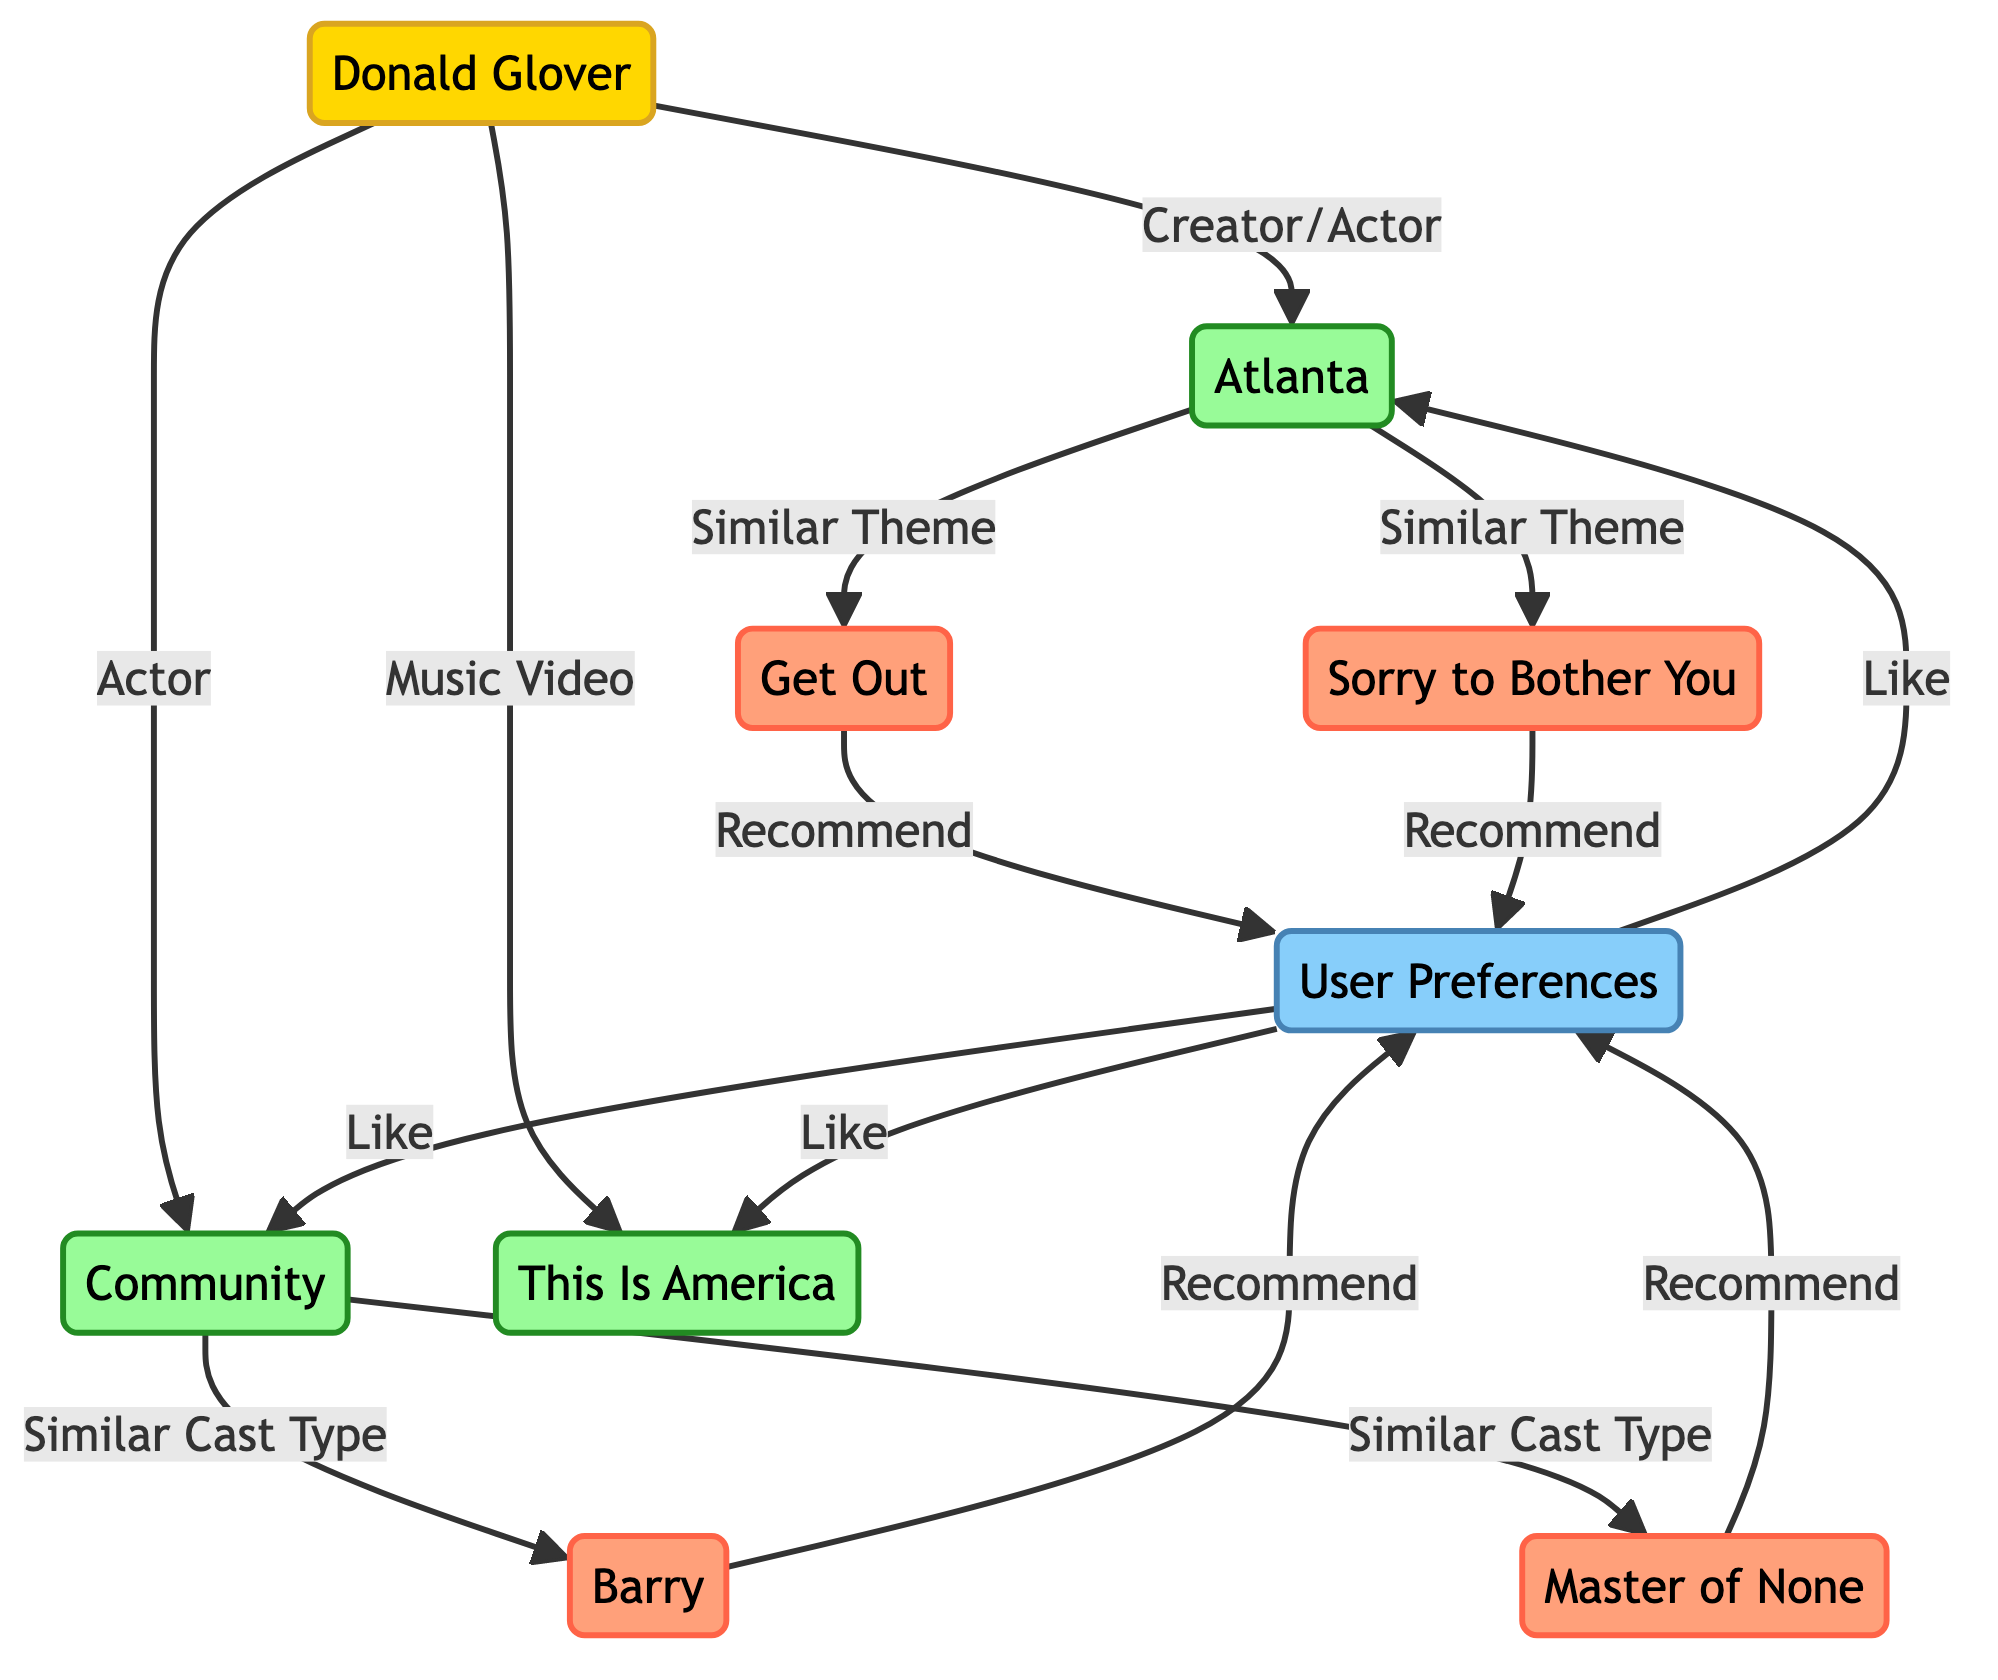What are the user preferences linked to in the diagram? The user preferences are linked to Atlanta, Community, and This Is America, as indicated by the arrows. Each shows the user's liking.
Answer: Atlanta, Community, This Is America How many movies are recommended in the diagram? There are two movies recommended (Get Out and Sorry to Bother You) based on their connections from Atlanta, which is liked by the user.
Answer: 2 Who is the central figure represented in the diagram? The central figure is Donald Glover. He is shown as a key node with connections to content and user preferences.
Answer: Donald Glover What type of relationship exists between Atlanta and Get Out? The relationship is a "Similar Theme," indicated by the labeling on the connecting edge from Atlanta to Get Out.
Answer: Similar Theme Which shows are related to Community in the diagram? The shows related to Community are Barry and Master of None, as indicated by the connections showing "Similar Cast Type."
Answer: Barry, Master of None What type of content is linked to "This Is America"? This Is America has a direct connection labeled as "Music Video" from Donald Glover, indicating its type of content.
Answer: Music Video How many content nodes are present in the diagram? Counting Atlanta, Community, This Is America, Get Out, Sorry to Bother You, Barry, and Master of None, there are seven content nodes in total.
Answer: 7 What kind of filtering method is illustrated in this diagram? The diagram illustrates a collaborative filtering method, represented by the relationships and recommendations based on user preferences.
Answer: Collaborative filtering Which user preference is connected to community as a liked content? The connection indicates that user preferences link to Community, reflecting their liking for it in the recommendation system.
Answer: Community 